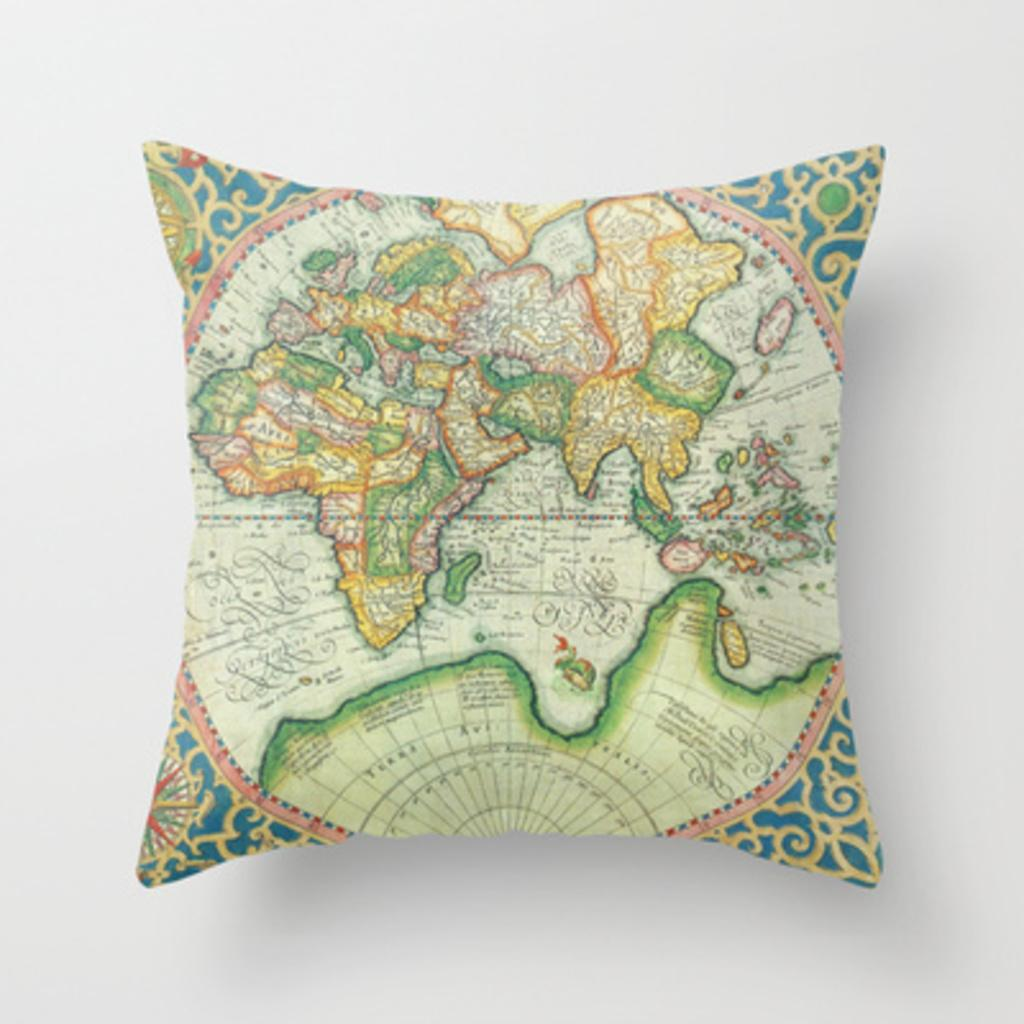What object can be seen in the image? There is a cushion in the image. What is on the cushion? There is a map on the cushion. What color is the background of the image? The background of the image is white in color. How many rings are visible on the cushion in the image? There are no rings visible on the cushion in the image. What is the cushion doing to get the attention of the viewer? The cushion is not actively trying to get the attention of the viewer; it is simply an object in the image. 